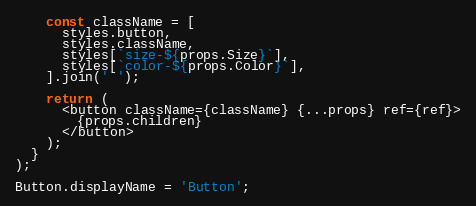<code> <loc_0><loc_0><loc_500><loc_500><_TypeScript_>    const className = [
      styles.button,
      styles.className,
      styles[`size-${props.Size}`],
      styles[`color-${props.Color}`],
    ].join(' ');

    return (
      <button className={className} {...props} ref={ref}>
        {props.children}
      </button>
    );
  }
);

Button.displayName = 'Button';
</code> 